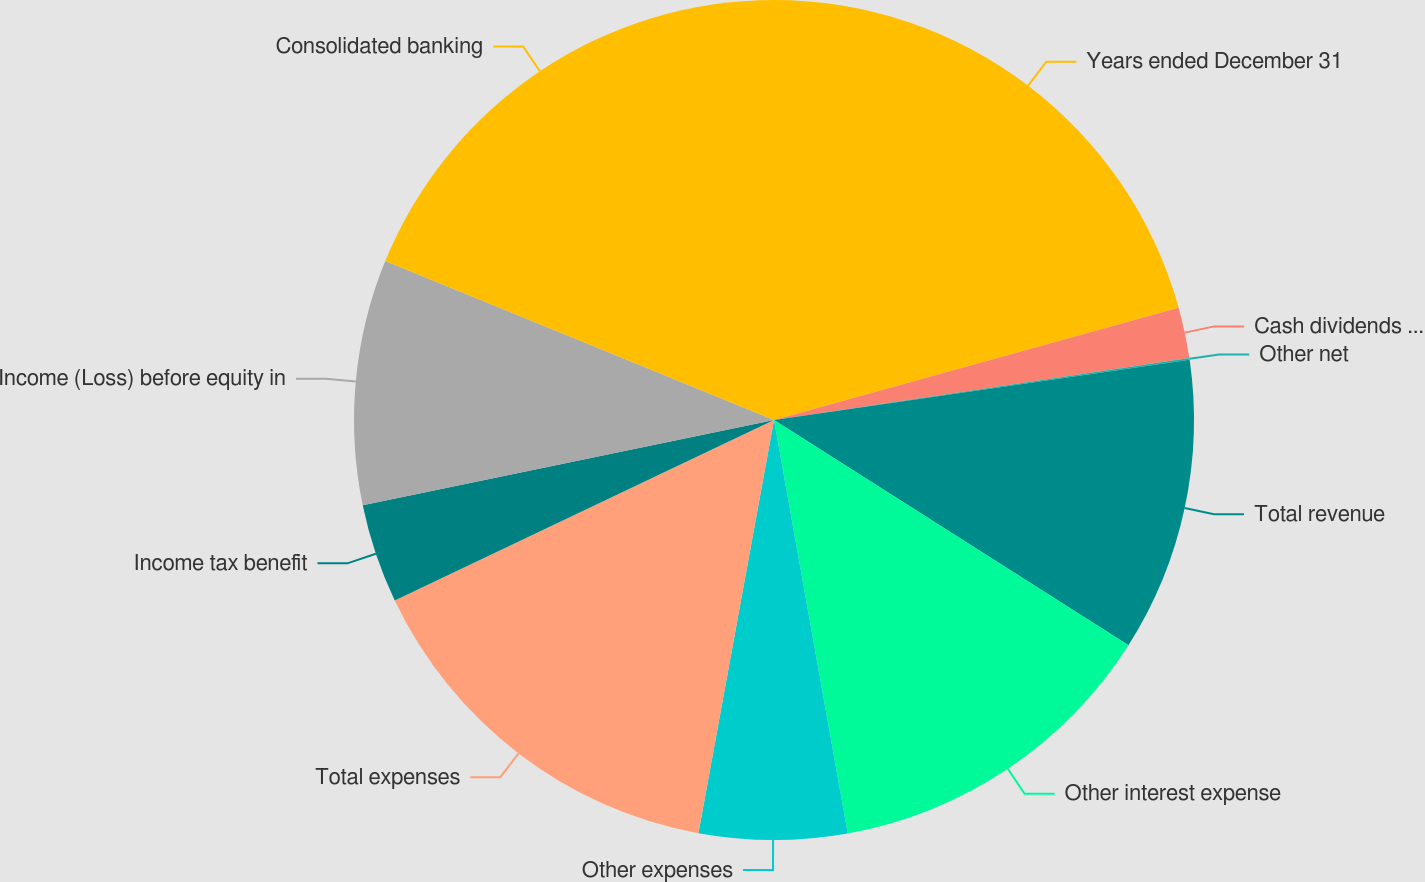Convert chart to OTSL. <chart><loc_0><loc_0><loc_500><loc_500><pie_chart><fcel>Years ended December 31<fcel>Cash dividends from<fcel>Other net<fcel>Total revenue<fcel>Other interest expense<fcel>Other expenses<fcel>Total expenses<fcel>Income tax benefit<fcel>Income (Loss) before equity in<fcel>Consolidated banking<nl><fcel>20.69%<fcel>1.95%<fcel>0.07%<fcel>11.3%<fcel>13.18%<fcel>5.69%<fcel>15.05%<fcel>3.82%<fcel>9.43%<fcel>18.82%<nl></chart> 